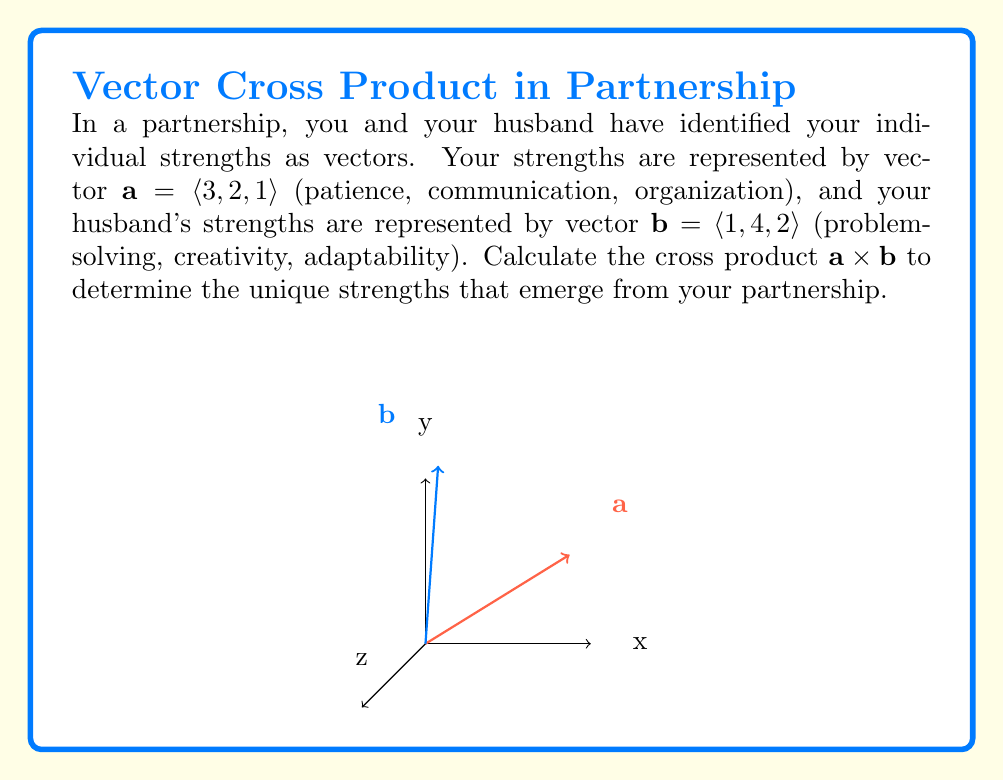Can you solve this math problem? To compute the cross product $\mathbf{a} \times \mathbf{b}$, we use the formula:

$$\mathbf{a} \times \mathbf{b} = \langle a_2b_3 - a_3b_2, a_3b_1 - a_1b_3, a_1b_2 - a_2b_1 \rangle$$

Where $\mathbf{a} = \langle a_1, a_2, a_3 \rangle$ and $\mathbf{b} = \langle b_1, b_2, b_3 \rangle$.

Step 1: Identify the components
$\mathbf{a} = \langle 3, 2, 1 \rangle$, so $a_1 = 3, a_2 = 2, a_3 = 1$
$\mathbf{b} = \langle 1, 4, 2 \rangle$, so $b_1 = 1, b_2 = 4, b_3 = 2$

Step 2: Calculate each component of the cross product
First component: $a_2b_3 - a_3b_2 = (2)(2) - (1)(4) = 4 - 4 = 0$
Second component: $a_3b_1 - a_1b_3 = (1)(1) - (3)(2) = 1 - 6 = -5$
Third component: $a_1b_2 - a_2b_1 = (3)(4) - (2)(1) = 12 - 2 = 10$

Step 3: Combine the results into a vector
$\mathbf{a} \times \mathbf{b} = \langle 0, -5, 10 \rangle$

This result represents the unique strengths that emerge from your partnership. The magnitude of each component indicates the strength of the synergy in that dimension, while the direction (positive or negative) suggests how these strengths complement or challenge each other.
Answer: $\mathbf{a} \times \mathbf{b} = \langle 0, -5, 10 \rangle$ 